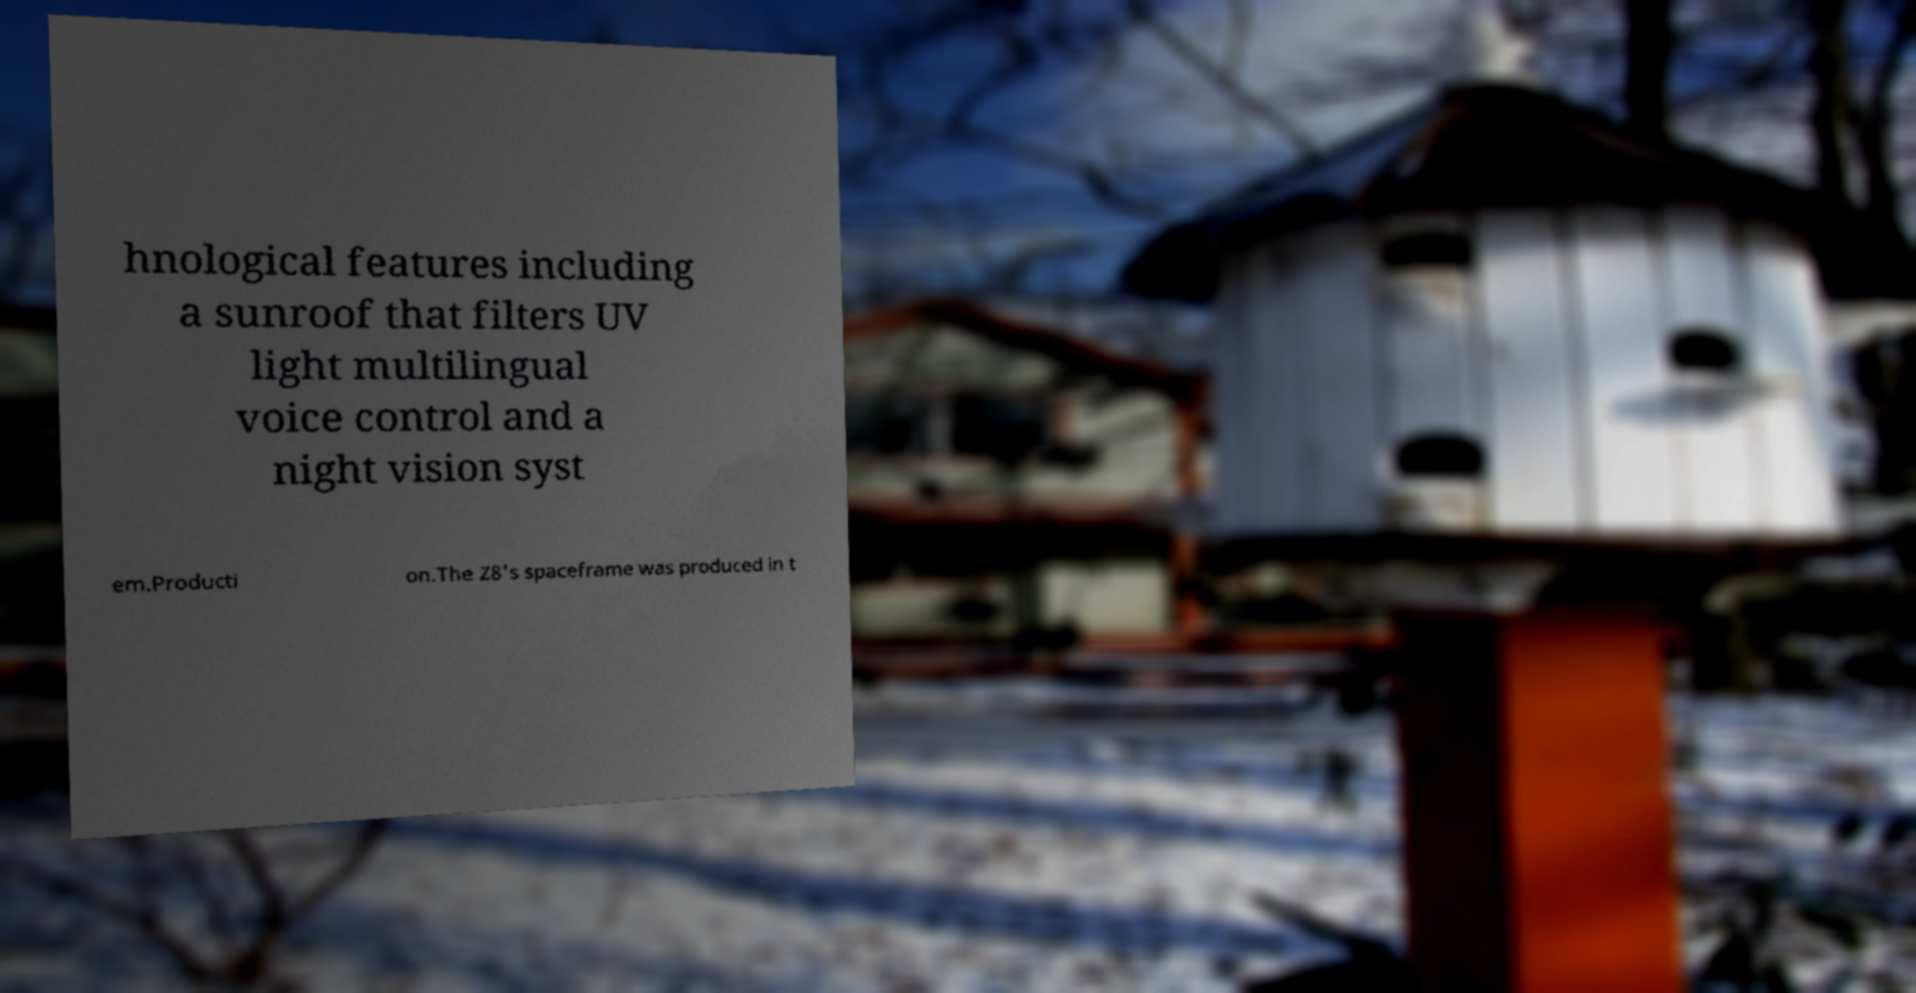Could you assist in decoding the text presented in this image and type it out clearly? hnological features including a sunroof that filters UV light multilingual voice control and a night vision syst em.Producti on.The Z8's spaceframe was produced in t 